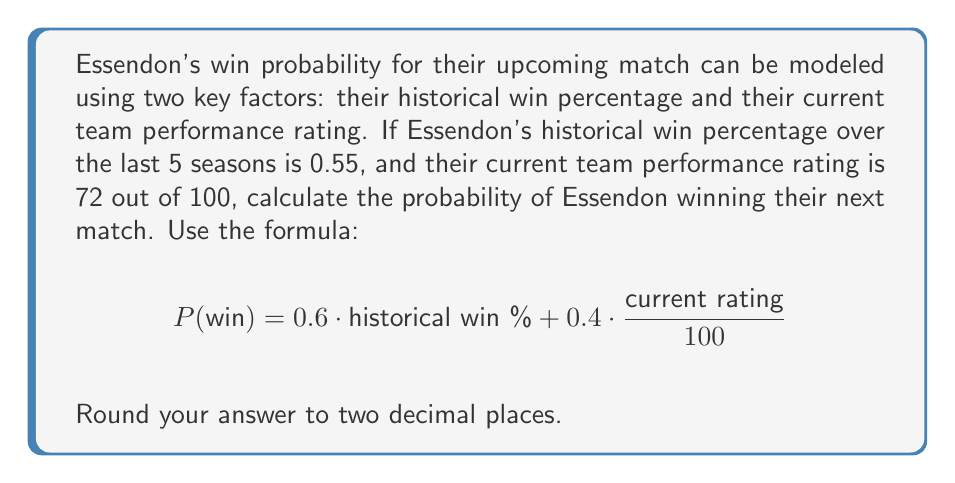Provide a solution to this math problem. To solve this problem, we'll follow these steps:

1. Identify the given values:
   - Historical win percentage = 0.55
   - Current team performance rating = 72 out of 100

2. Plug these values into the given formula:
   $$P(\text{win}) = 0.6 \cdot \text{historical win %} + 0.4 \cdot \frac{\text{current rating}}{100}$$

3. Calculate the first term:
   $$0.6 \cdot 0.55 = 0.33$$

4. Calculate the second term:
   $$0.4 \cdot \frac{72}{100} = 0.4 \cdot 0.72 = 0.288$$

5. Sum the two terms:
   $$P(\text{win}) = 0.33 + 0.288 = 0.618$$

6. Round the result to two decimal places:
   $$P(\text{win}) \approx 0.62$$

Therefore, the probability of Essendon winning their next match is 0.62 or 62%.
Answer: 0.62 